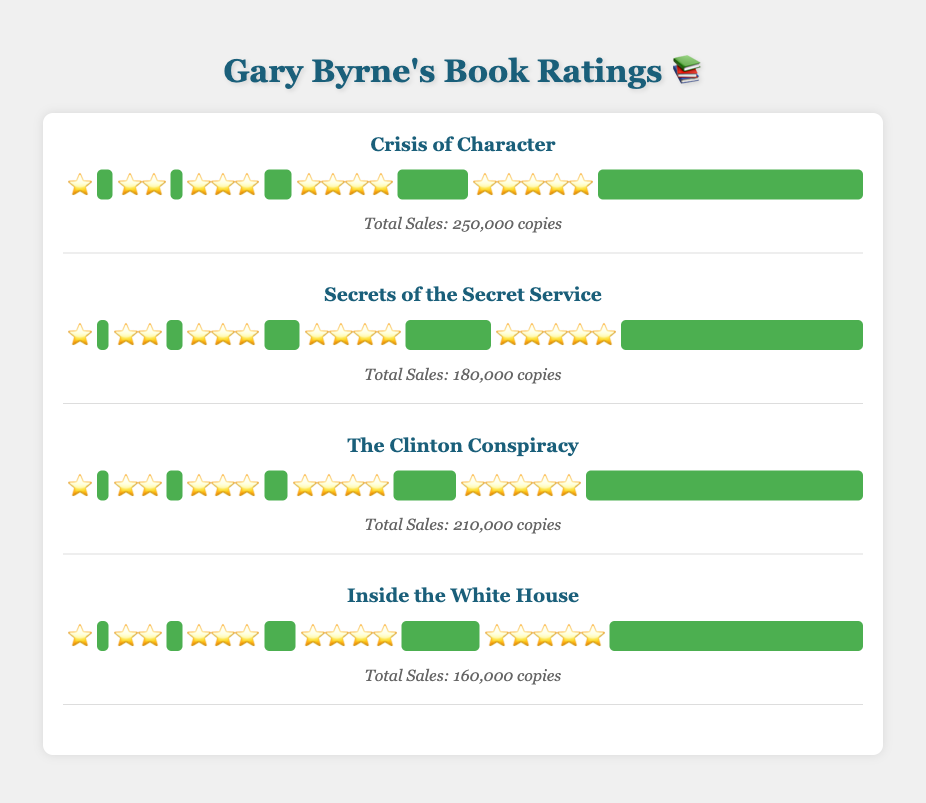Which book has the highest number of 5-star ratings? To find this, look at the ratings for each book and identify the one with the most 5-star ratings. "The Clinton Conspiracy" has 71, which is the highest.
Answer: "The Clinton Conspiracy" How many total sales did "Inside the White House" make? Locate the total sales information for the book "Inside the White House". It sold 160,000 copies.
Answer: 160,000 What's the sum of 4-star ratings for all the books? Add up the 4-star ratings of all the books: 18 (Crisis of Character) + 22 (Secrets of the Secret Service) + 16 (The Clinton Conspiracy) + 20 (Inside the White House) = 76
Answer: 76 Which book has the least number of 1-star ratings? Compare the number of 1-star ratings for all the books. "Secrets of the Secret Service," "The Clinton Conspiracy," and "Inside the White House" each have the least, with 3.
Answer: "Secrets of the Secret Service", "The Clinton Conspiracy", "Inside the White House" Which book shows the highest diversity in ratings based on the widest spread among all star ratings? Examine each book's ratings distribution for the widest variation from the lowest to the highest ratings. "Crisis of Character" has a distribution range from 4 to 68 ratings.
Answer: "Crisis of Character" What is the average number of 3-star ratings given to Gary Byrne's books? Add up the 3-star ratings and divide by the number of books: (7+9+6+8)/4 = 30/4 = 7.5
Answer: 7.5 Between "Crisis of Character" and "Inside the White House," which book had better average ratings? For each book calculate the weighted average rating by using the formula (sum of star ratings multiplied by their respective frequency) divided by the total number of ratings: 
- Crisis of Character: 
   (5*68 + 4*18 + 3*7 + 2*3 + 1*4) / 100 = (340 + 72 + 21 + 6 + 4) / 100 = 443 / 100 = 4.43
- Inside the White House: 
   (5*65 + 4*20 + 3*8 + 2*4 + 1*3) / 100 = (325 + 80 + 24 + 8 + 3) / 100 = 440 / 100 = 4.40
Therefore, "Crisis of Character" had a slightly better average rating.
Answer: "Crisis of Character" How does "Secrets of the Secret Service" compare to "The Clinton Conspiracy" in terms of total sales? Compare the total sales listed for both books. "The Clinton Conspiracy" sold 210,000 copies while "Secrets of the Secret Service" sold 180,000 copies, so "The Clinton Conspiracy" had higher sales.
Answer: "The Clinton Conspiracy" What percentage of ratings for "Secrets of the Secret Service" are 5-star? Calculate the percentage by dividing the number of 5-star ratings by the total number of ratings and then multiplying by 100: 62 / (62+22+9+4+3) * 100 = 62/100 * 100 = 62%
Answer: 62% For each book, order them by highest to lowest sales. Examine the sales data for each book and order them:
1. Crisis of Character: 250,000
2. The Clinton Conspiracy: 210,000
3. Secrets of the Secret Service: 180,000
4. Inside the White House: 160,000
Answer: 1. Crisis of Character, 2. The Clinton Conspiracy, 3. Secrets of the Secret Service, 4. Inside the White House Which book has the smallest number of total ratings? Add the ratings for each book and compare them: 
- Crisis of Character: 100 ratings
- Secrets of the Secret Service: 100 ratings
- The Clinton Conspiracy: 100 ratings
- Inside the White House: 100 ratings
Since all books have the same total number of ratings, there is no book with a smaller total.
Answer: All books are tied 